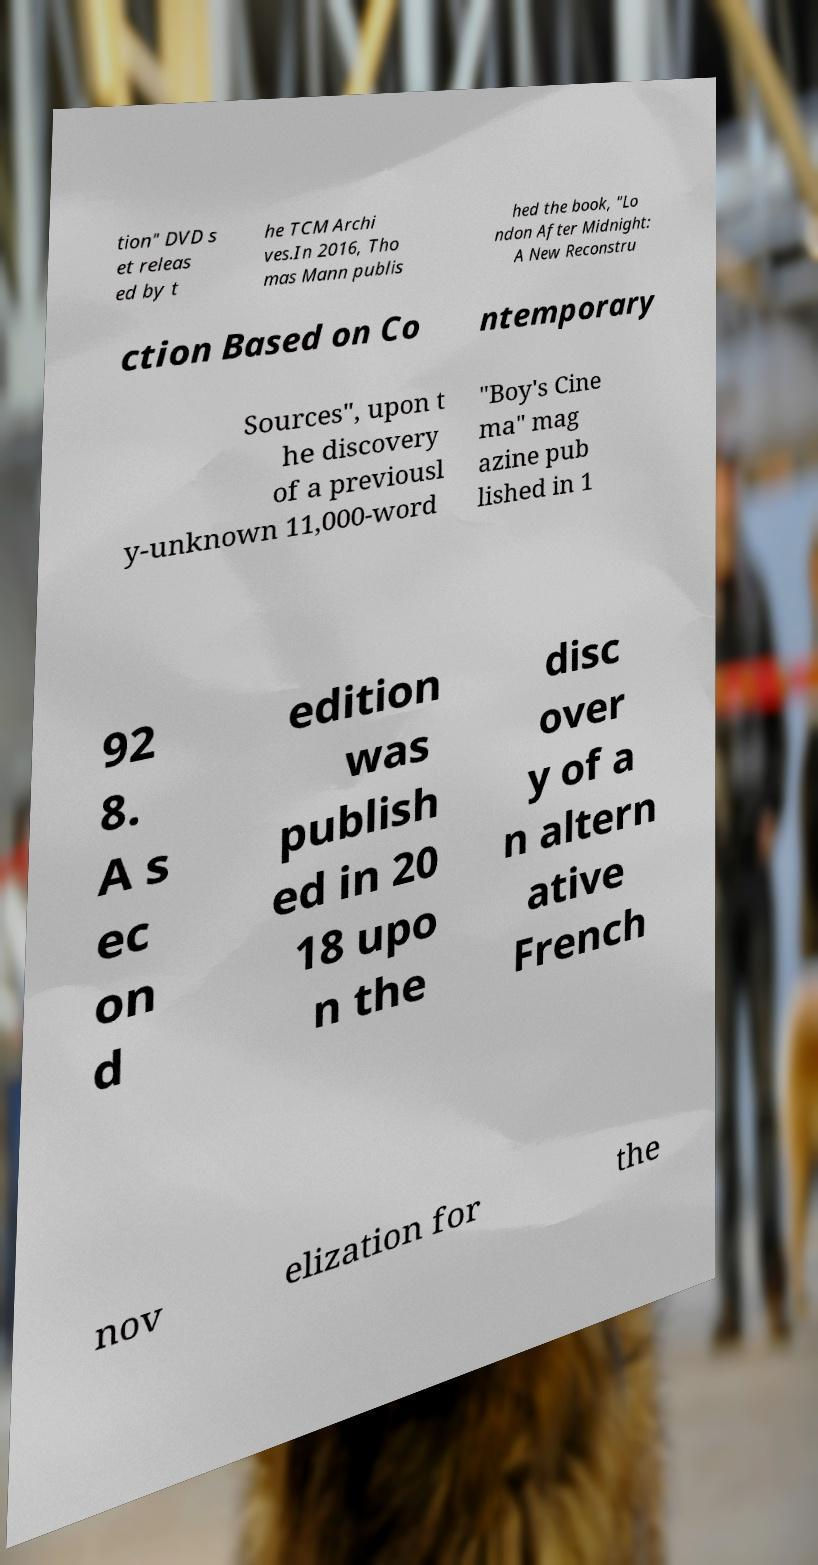I need the written content from this picture converted into text. Can you do that? tion" DVD s et releas ed by t he TCM Archi ves.In 2016, Tho mas Mann publis hed the book, "Lo ndon After Midnight: A New Reconstru ction Based on Co ntemporary Sources", upon t he discovery of a previousl y-unknown 11,000-word "Boy's Cine ma" mag azine pub lished in 1 92 8. A s ec on d edition was publish ed in 20 18 upo n the disc over y of a n altern ative French nov elization for the 